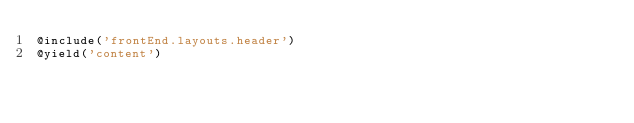<code> <loc_0><loc_0><loc_500><loc_500><_PHP_>@include('frontEnd.layouts.header')
@yield('content')</code> 